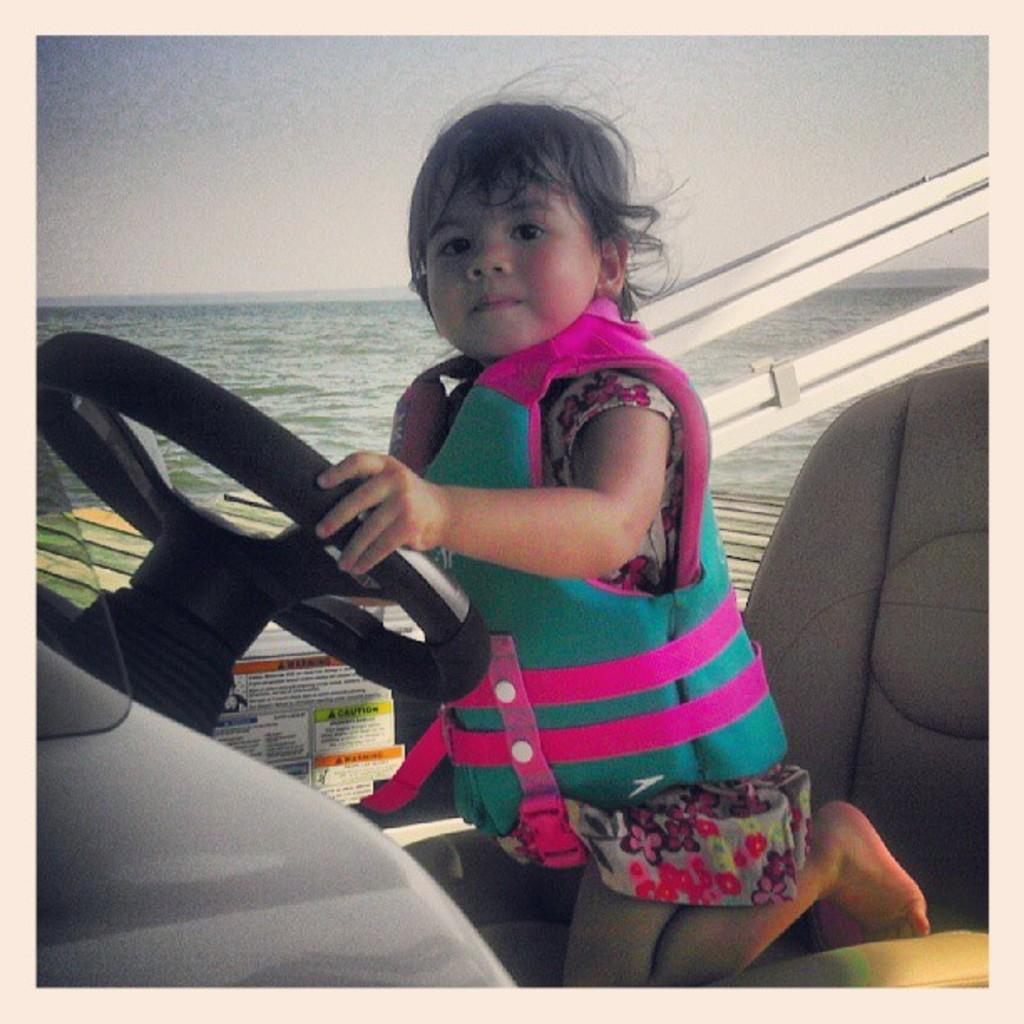Who is the main subject in the image? There is a girl in the image. What is the girl doing in the image? The girl is sitting on a chair and holding a steering wheel. What can be seen in the background of the image? Water and the sky are visible in the background of the image. How many geese are swimming in the water behind the girl? There are no geese visible in the image; only water and the sky can be seen in the background. 